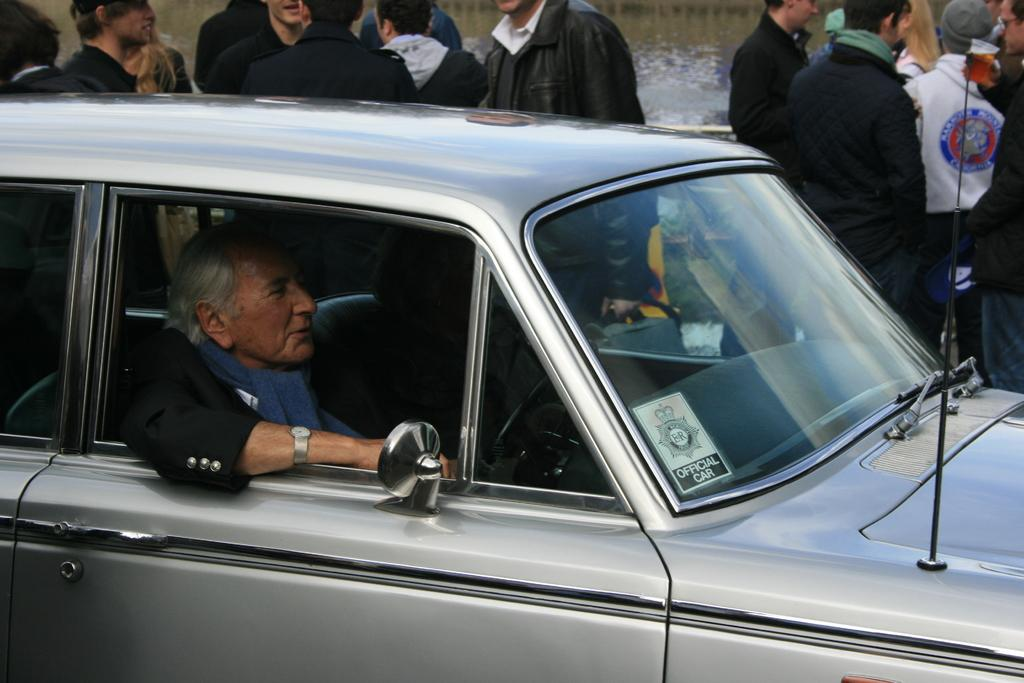Who is present in the image? There is a woman in the image. What is the woman doing in the image? The woman is sitting in a car and riding in it. Are there any other people in the image? Yes, there is a group of people standing near the car. What type of fan is visible in the image? There is no fan present in the image. What color is the silver object in the image? There is no silver object present in the image. 